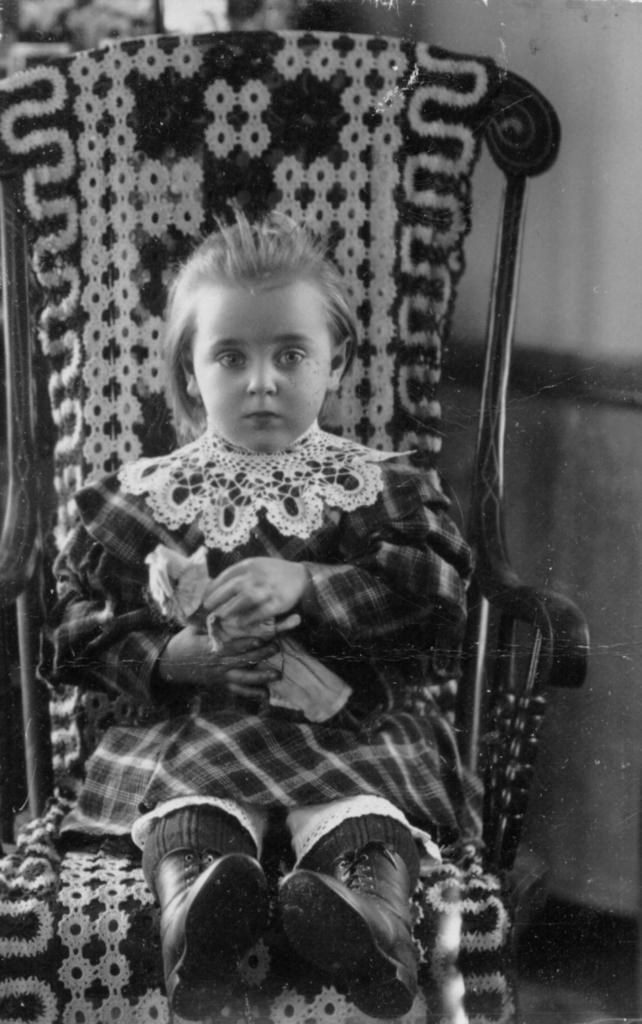Who is the main subject in the image? There is a girl in the image. What is the girl doing in the image? The girl is sitting on a chair. What is the girl holding in the image? The girl is holding a toy. What is the girl wearing in the image? The girl is wearing a dress and boots. What type of oil can be seen dripping from the girl's hair in the image? There is no oil or any dripping substance visible in the girl's hair in the image. 